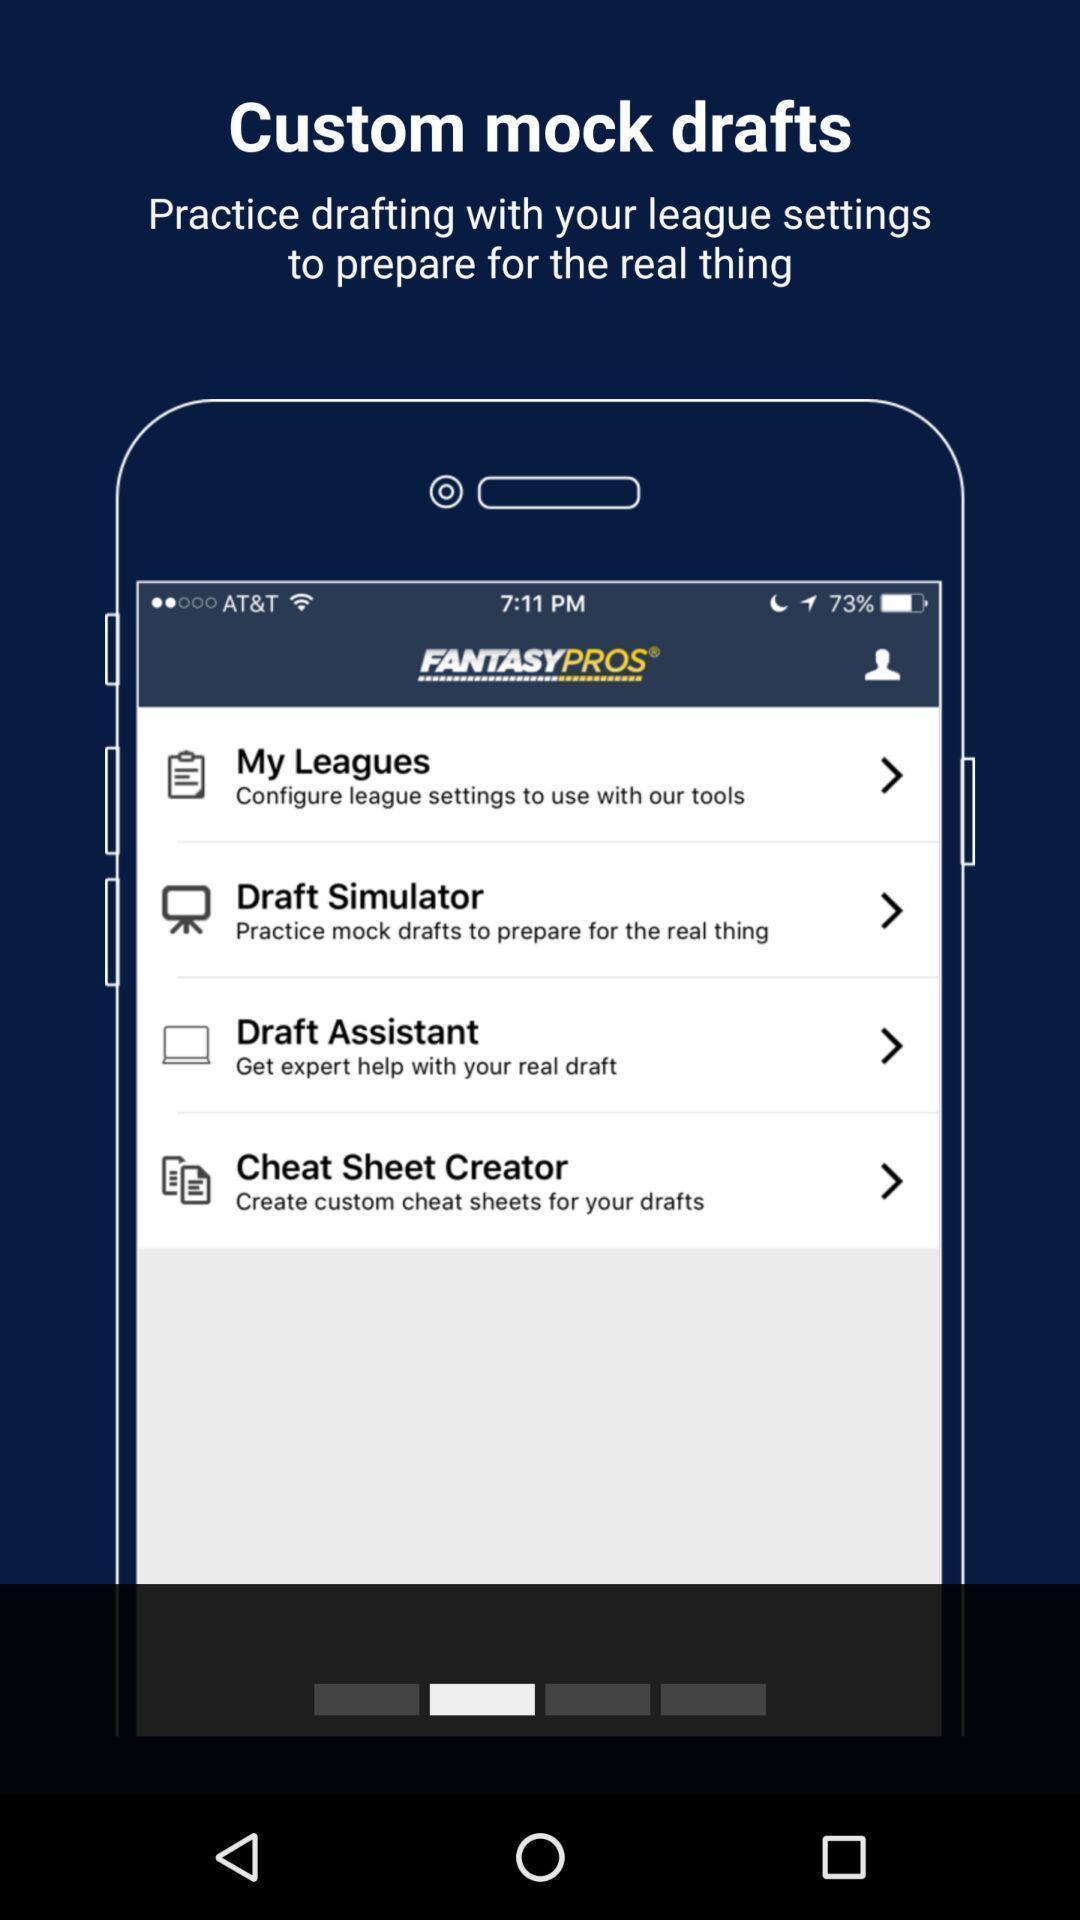Describe the visual elements of this screenshot. Starting page for a leagues app. 